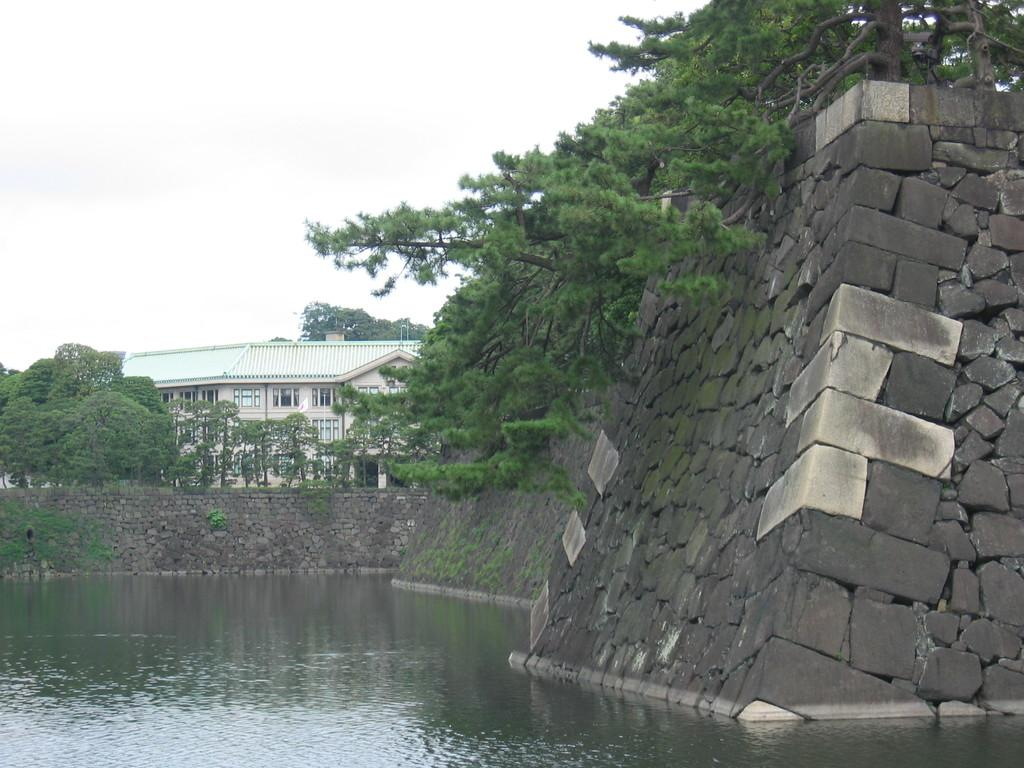What type of structure can be seen in the image? There is a house in the image. What is located near the house? There are trees in the image. What is the color of the sky in the image? The sky is visible in the image. Are there any openings in the house? Yes, there are windows in the house. Can you see any gold items in the image? There is no gold item present in the image. Is your dad in the image? There is no person, including your dad, present in the image. 